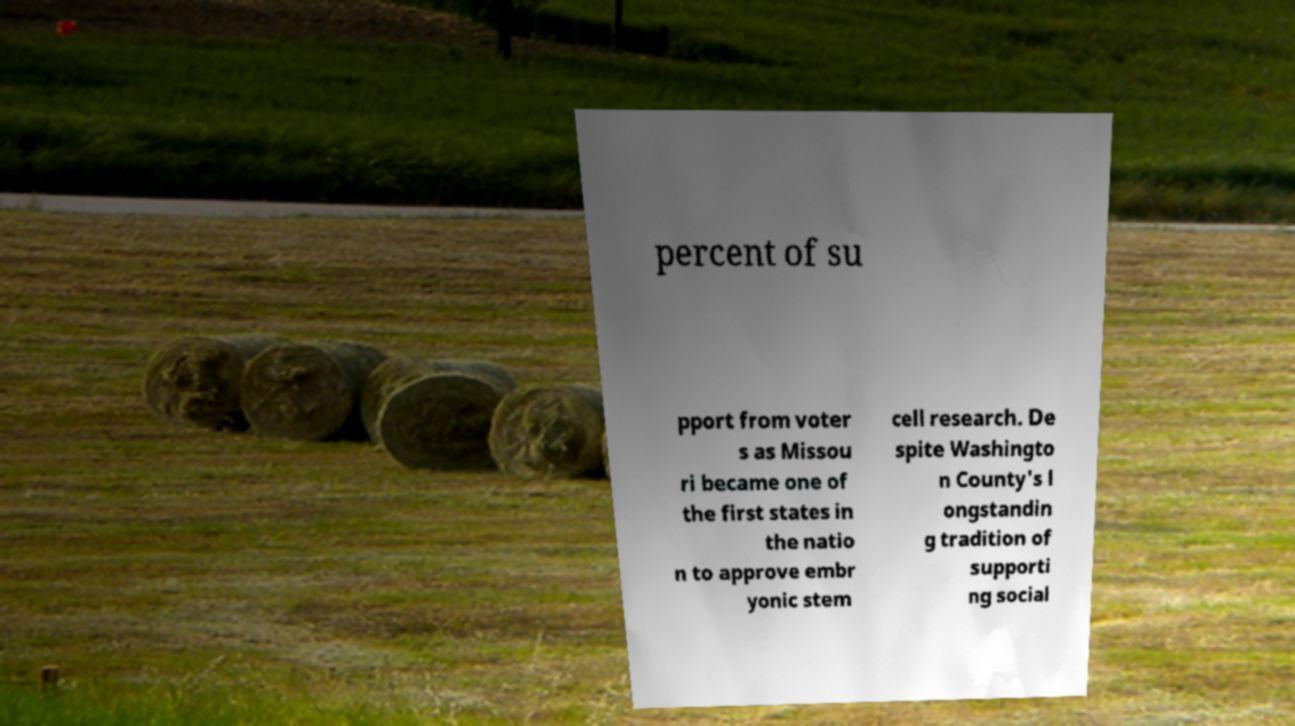Please identify and transcribe the text found in this image. percent of su pport from voter s as Missou ri became one of the first states in the natio n to approve embr yonic stem cell research. De spite Washingto n County's l ongstandin g tradition of supporti ng social 